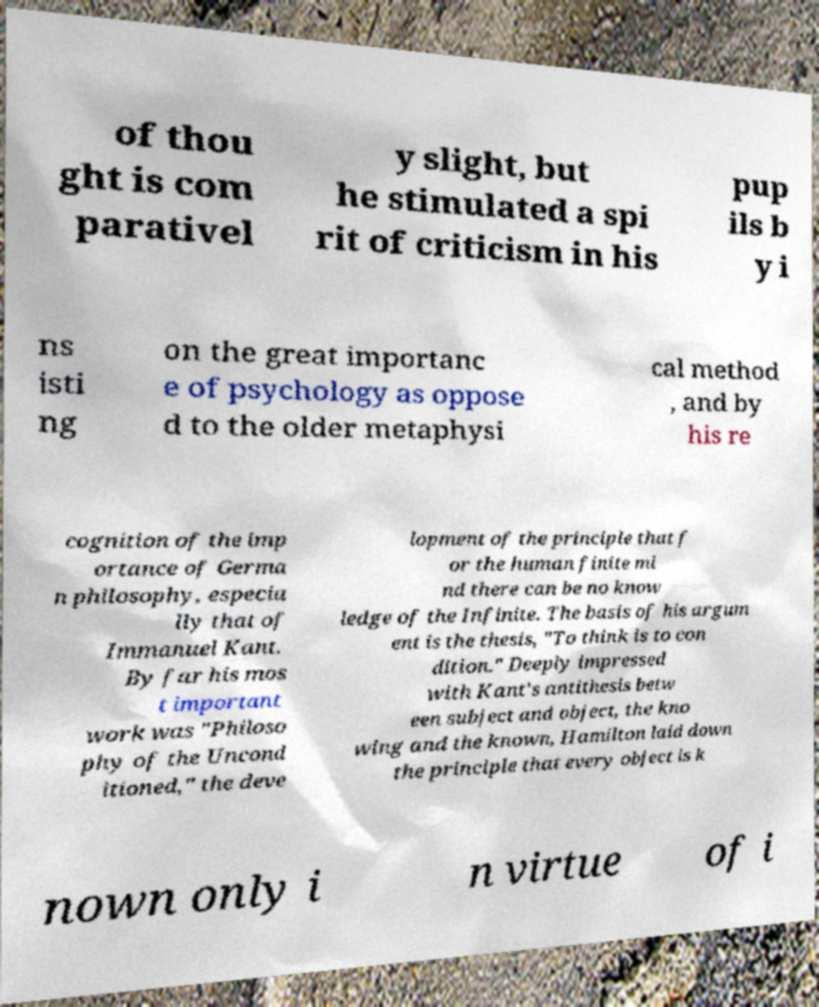What messages or text are displayed in this image? I need them in a readable, typed format. of thou ght is com parativel y slight, but he stimulated a spi rit of criticism in his pup ils b y i ns isti ng on the great importanc e of psychology as oppose d to the older metaphysi cal method , and by his re cognition of the imp ortance of Germa n philosophy, especia lly that of Immanuel Kant. By far his mos t important work was "Philoso phy of the Uncond itioned," the deve lopment of the principle that f or the human finite mi nd there can be no know ledge of the Infinite. The basis of his argum ent is the thesis, "To think is to con dition." Deeply impressed with Kant's antithesis betw een subject and object, the kno wing and the known, Hamilton laid down the principle that every object is k nown only i n virtue of i 